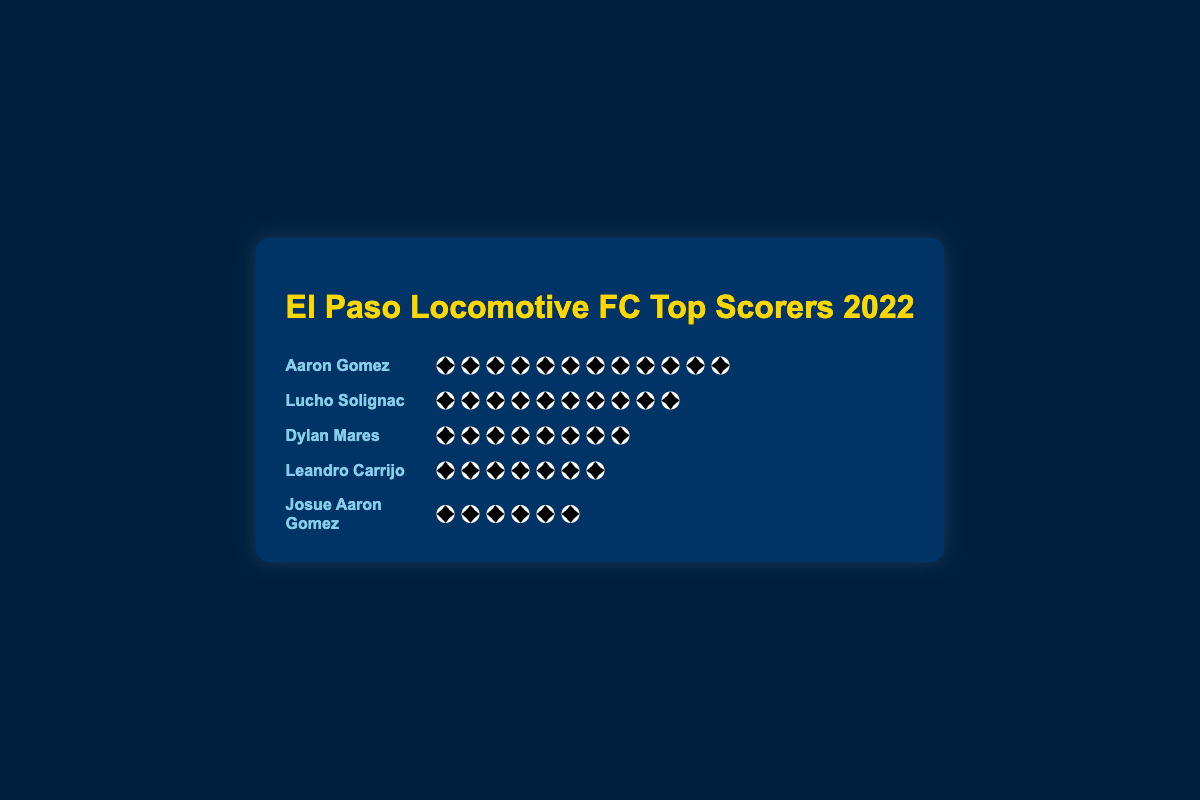Who is the top scorer for El Paso Locomotive FC in the 2022 season? According to the figure, Aaron Gomez is represented by the most soccer ball icons, indicating he scored the most goals.
Answer: Aaron Gomez How many goals did Lucho Solignac score in the 2022 season? Referring to the figure, Lucho Solignac has ten soccer ball icons next to his name.
Answer: 10 What is the total number of goals scored by Dylan Mares and Leandro Carrijo combined? Dylan Mares has eight soccer ball icons, and Leandro Carrijo has seven. Adding them together gives 8 + 7.
Answer: 15 Who scored fewer goals: Josue Aaron Gomez or Leandro Carrijo? Josue Aaron Gomez has six soccer ball icons, while Leandro Carrijo has seven. Comparing these, Josue Aaron Gomez scored fewer goals.
Answer: Josue Aaron Gomez How many more goals did Aaron Gomez score than Josue Aaron Gomez? Aaron Gomez scored twelve goals while Josue Aaron Gomez scored six goals. Subtracting these gives 12 - 6.
Answer: 6 What is the combined goal count of all the top five scorers? The goals are as follows: Aaron Gomez (12), Lucho Solignac (10), Dylan Mares (8), Leandro Carrijo (7), Josue Aaron Gomez (6). Adding them together results in 12 + 10 + 8 + 7 + 6.
Answer: 43 Who is the third highest goal scorer? In the figure, the goal counts are as follows: Aaron Gomez (12), Lucho Solignac (10), Dylan Mares (8). Dylan Mares is the third highest scorer.
Answer: Dylan Mares What is the median number of goals scored by these top players? The goal counts in ascending order are 6, 7, 8, 10, 12. The median value is the middle number, which is 8.
Answer: 8 How many goals did the second highest scorer score? Lucho Solignac is the second highest scorer with ten soccer ball icons.
Answer: 10 Arrange the players in order of their goals from least to most. Viewing the figure, the goals from least to most are as follows: Josue Aaron Gomez (6), Leandro Carrijo (7), Dylan Mares (8), Lucho Solignac (10), Aaron Gomez (12).
Answer: Josue Aaron Gomez, Leandro Carrijo, Dylan Mares, Lucho Solignac, Aaron Gomez 